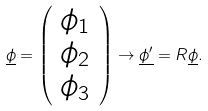<formula> <loc_0><loc_0><loc_500><loc_500>\underline { \phi } = \left ( \begin{array} { c } \phi _ { 1 } \\ \phi _ { 2 } \\ \phi _ { 3 } \end{array} \right ) \rightarrow \underline { \phi ^ { \prime } } = { R } \underline { \phi } .</formula> 